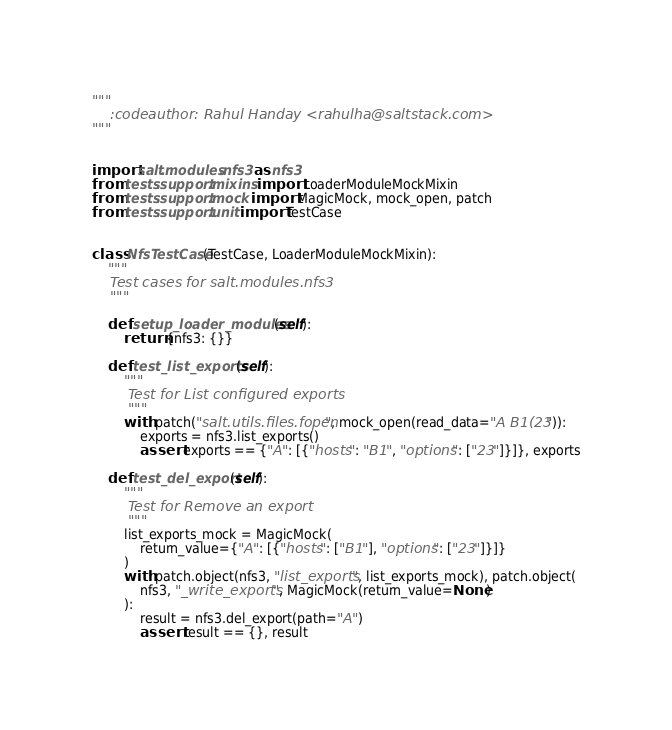<code> <loc_0><loc_0><loc_500><loc_500><_Python_>"""
    :codeauthor: Rahul Handay <rahulha@saltstack.com>
"""


import salt.modules.nfs3 as nfs3
from tests.support.mixins import LoaderModuleMockMixin
from tests.support.mock import MagicMock, mock_open, patch
from tests.support.unit import TestCase


class NfsTestCase(TestCase, LoaderModuleMockMixin):
    """
    Test cases for salt.modules.nfs3
    """

    def setup_loader_modules(self):
        return {nfs3: {}}

    def test_list_exports(self):
        """
        Test for List configured exports
        """
        with patch("salt.utils.files.fopen", mock_open(read_data="A B1(23")):
            exports = nfs3.list_exports()
            assert exports == {"A": [{"hosts": "B1", "options": ["23"]}]}, exports

    def test_del_export(self):
        """
        Test for Remove an export
        """
        list_exports_mock = MagicMock(
            return_value={"A": [{"hosts": ["B1"], "options": ["23"]}]}
        )
        with patch.object(nfs3, "list_exports", list_exports_mock), patch.object(
            nfs3, "_write_exports", MagicMock(return_value=None)
        ):
            result = nfs3.del_export(path="A")
            assert result == {}, result
</code> 